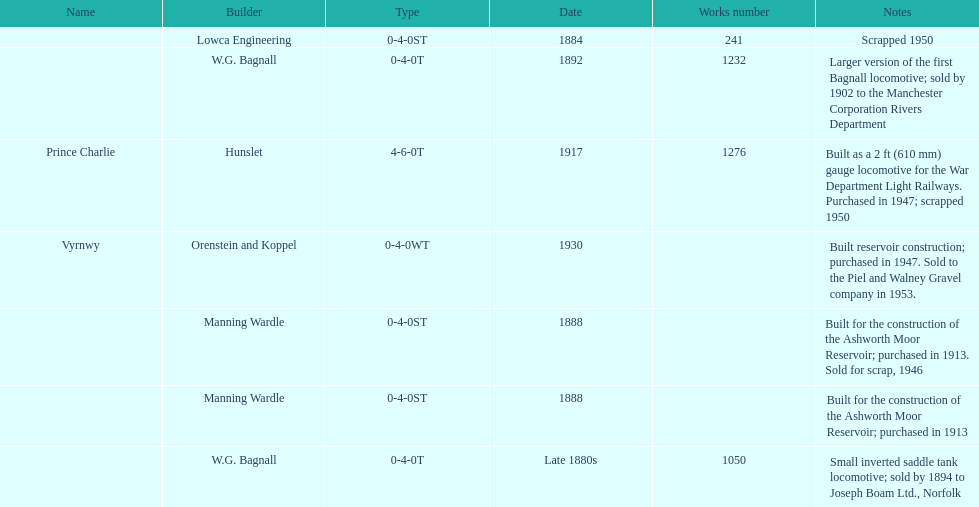How many locomotives were built for the construction of the ashworth moor reservoir? 2. 